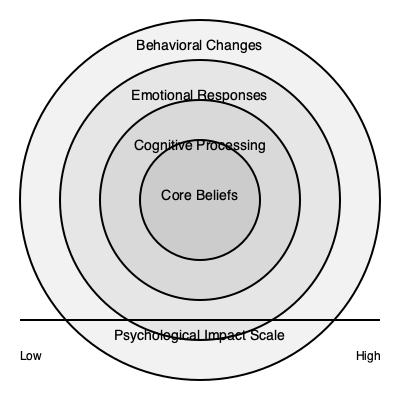Based on the multi-layered brain diagram depicting the psychological impact of riot experiences on police officers, which layer is most likely to be affected first and most intensely during a high-stress event like the Bathurst motorcycle race riots, and why? To answer this question, we need to analyze the layers of the brain diagram and their relationship to psychological responses during high-stress events:

1. The outermost layer represents "Behavioral Changes." These are observable actions and reactions that result from internal processes.

2. The second layer depicts "Emotional Responses." This includes immediate feelings and affect experienced during and after the event.

3. The third layer shows "Cognitive Processing." This involves thought patterns, decision-making, and information processing.

4. The innermost layer represents "Core Beliefs." These are fundamental assumptions about oneself, others, and the world.

During a high-stress event like a riot:

1. The brain's limbic system, responsible for emotional processing, is activated first through the amygdala's threat detection mechanism.

2. This rapid emotional response occurs before cognitive processing can fully engage, as the brain prioritizes survival-related reactions.

3. Emotional responses can be intense and immediate, affecting an officer's perception and reaction to the situation.

4. While cognitive processing and core beliefs may be impacted, these typically require more time to be significantly altered.

5. Behavioral changes, while observable, are usually a result of the emotional and cognitive processes rather than the initial response.

Therefore, the "Emotional Responses" layer is most likely to be affected first and most intensely during a high-stress event like the Bathurst motorcycle race riots. This is due to the brain's prioritization of rapid emotional processing in threatening situations, which occurs before higher-order cognitive functions fully engage.
Answer: Emotional Responses layer 